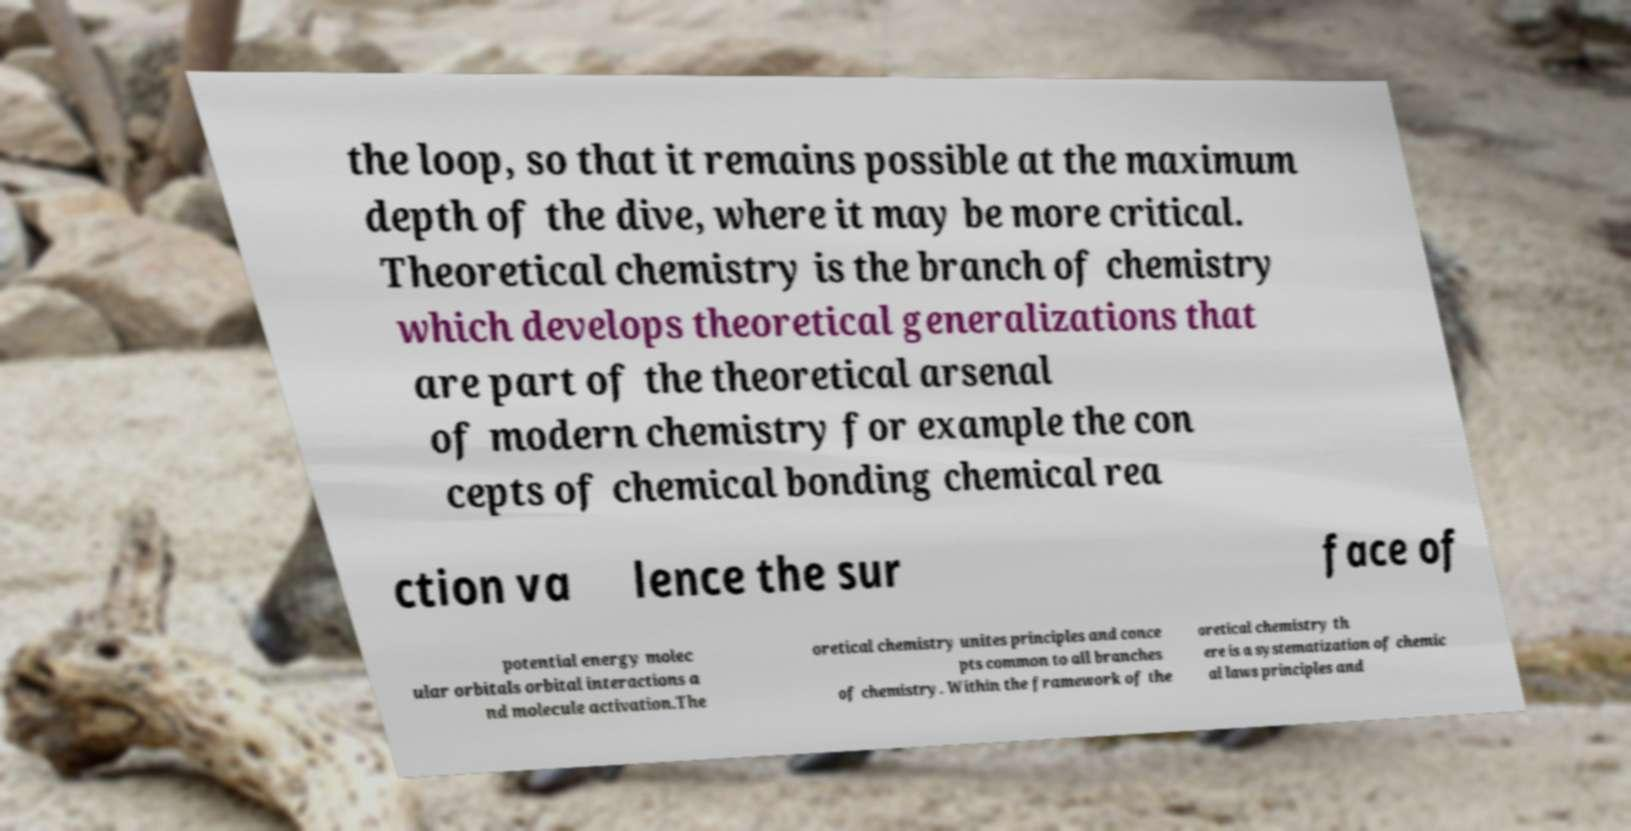What messages or text are displayed in this image? I need them in a readable, typed format. the loop, so that it remains possible at the maximum depth of the dive, where it may be more critical. Theoretical chemistry is the branch of chemistry which develops theoretical generalizations that are part of the theoretical arsenal of modern chemistry for example the con cepts of chemical bonding chemical rea ction va lence the sur face of potential energy molec ular orbitals orbital interactions a nd molecule activation.The oretical chemistry unites principles and conce pts common to all branches of chemistry. Within the framework of the oretical chemistry th ere is a systematization of chemic al laws principles and 